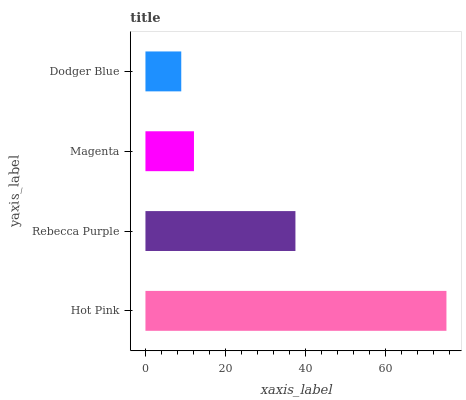Is Dodger Blue the minimum?
Answer yes or no. Yes. Is Hot Pink the maximum?
Answer yes or no. Yes. Is Rebecca Purple the minimum?
Answer yes or no. No. Is Rebecca Purple the maximum?
Answer yes or no. No. Is Hot Pink greater than Rebecca Purple?
Answer yes or no. Yes. Is Rebecca Purple less than Hot Pink?
Answer yes or no. Yes. Is Rebecca Purple greater than Hot Pink?
Answer yes or no. No. Is Hot Pink less than Rebecca Purple?
Answer yes or no. No. Is Rebecca Purple the high median?
Answer yes or no. Yes. Is Magenta the low median?
Answer yes or no. Yes. Is Hot Pink the high median?
Answer yes or no. No. Is Dodger Blue the low median?
Answer yes or no. No. 